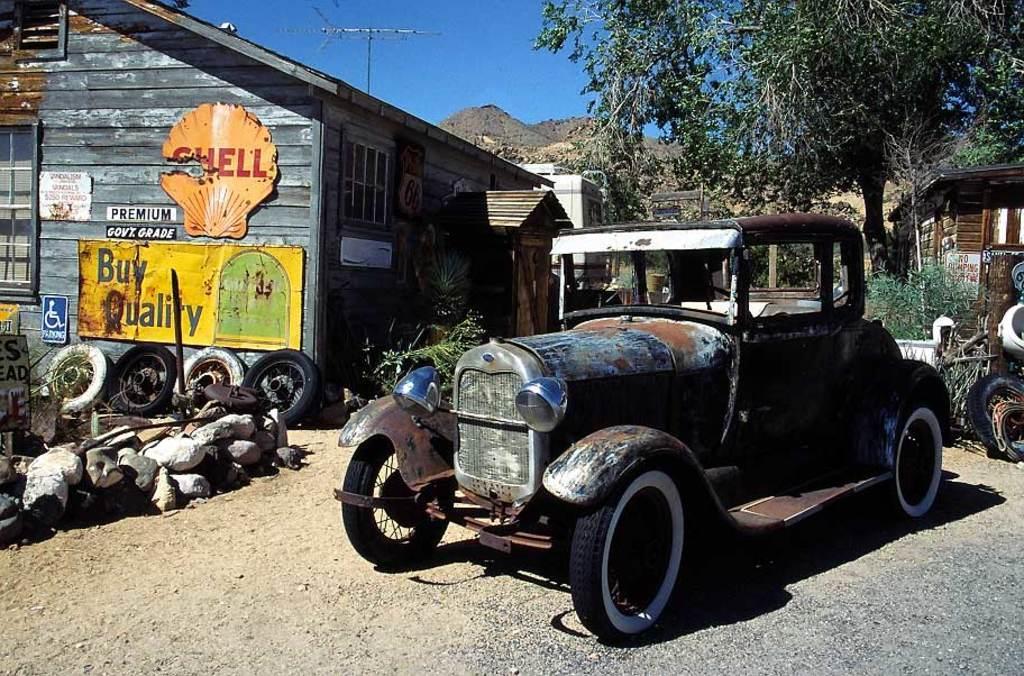How would you summarize this image in a sentence or two? Here it is a jeep which is in old condition in the right side there are trees. In the left side it is a wooden house. 